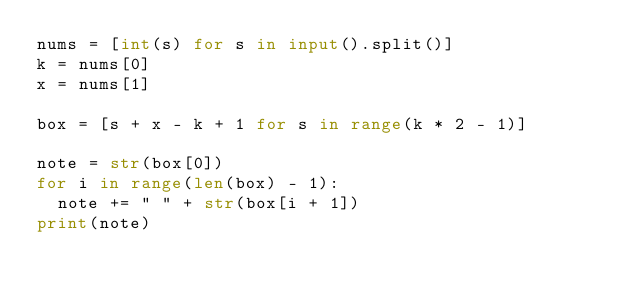<code> <loc_0><loc_0><loc_500><loc_500><_Python_>nums = [int(s) for s in input().split()]
k = nums[0]
x = nums[1]

box = [s + x - k + 1 for s in range(k * 2 - 1)]

note = str(box[0])
for i in range(len(box) - 1):
  note += " " + str(box[i + 1])
print(note)</code> 